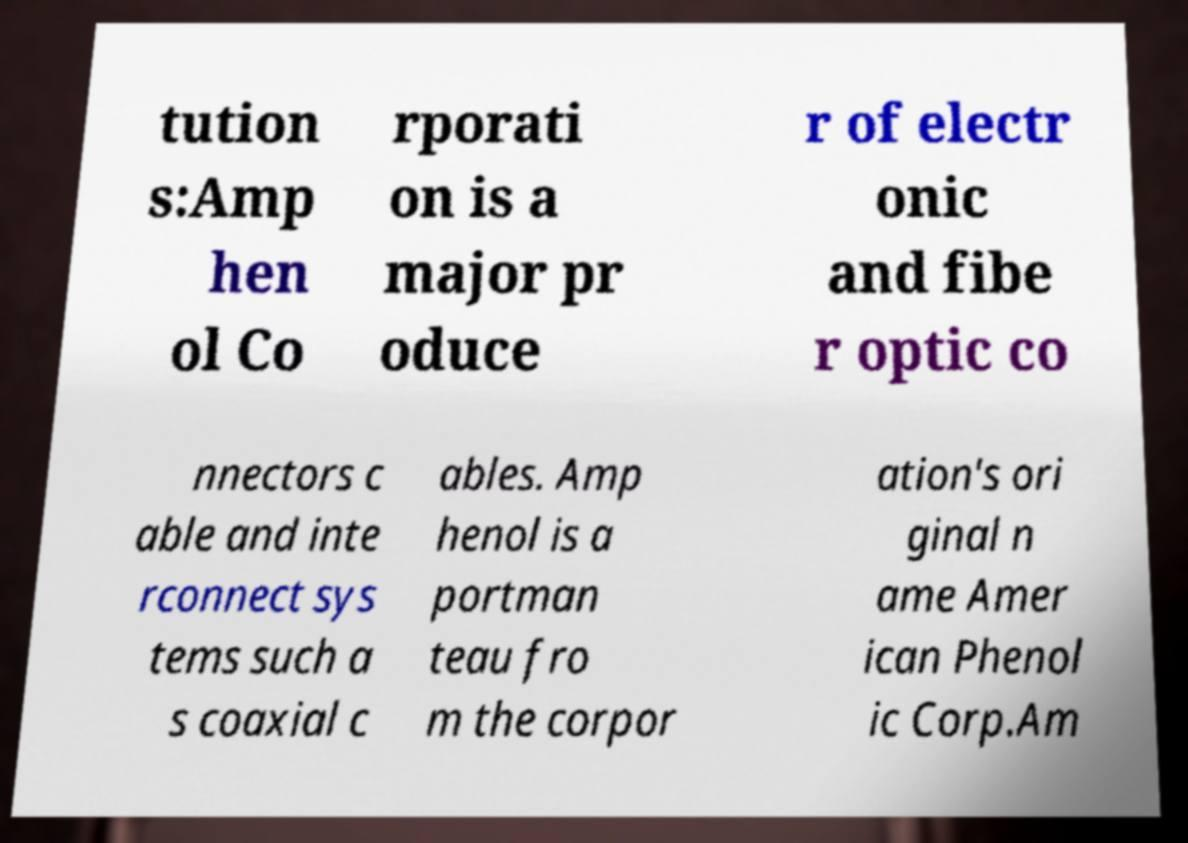I need the written content from this picture converted into text. Can you do that? tution s:Amp hen ol Co rporati on is a major pr oduce r of electr onic and fibe r optic co nnectors c able and inte rconnect sys tems such a s coaxial c ables. Amp henol is a portman teau fro m the corpor ation's ori ginal n ame Amer ican Phenol ic Corp.Am 